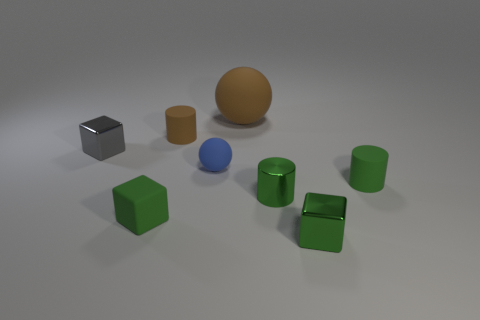There is a tiny green object left of the shiny cylinder; what material is it?
Your answer should be compact. Rubber. What number of red things are either tiny cubes or large things?
Give a very brief answer. 0. Is the material of the big object the same as the small green object right of the green metal block?
Provide a succinct answer. Yes. Is the number of blue rubber spheres that are to the left of the small brown rubber thing the same as the number of shiny cylinders that are on the left side of the gray block?
Your response must be concise. Yes. Do the brown cylinder and the matte sphere that is in front of the tiny gray block have the same size?
Provide a succinct answer. Yes. Are there more green matte objects that are on the left side of the blue matte ball than tiny metallic objects?
Offer a very short reply. No. How many other blue rubber objects have the same size as the blue object?
Provide a short and direct response. 0. Does the rubber cylinder that is in front of the tiny gray block have the same size as the sphere that is behind the tiny gray block?
Provide a short and direct response. No. Is the number of small metal cylinders that are to the right of the tiny green rubber cylinder greater than the number of blue matte objects that are behind the brown ball?
Offer a very short reply. No. What number of tiny rubber things have the same shape as the big matte object?
Provide a succinct answer. 1. 